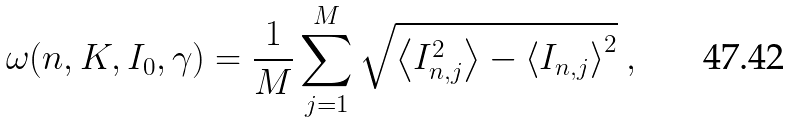<formula> <loc_0><loc_0><loc_500><loc_500>\omega ( n , K , I _ { 0 } , \gamma ) = \frac { 1 } { M } \sum ^ { M } _ { j = 1 } \sqrt { \left < I _ { n , j } ^ { 2 } \right > - \left < I _ { n , j } \right > ^ { 2 } } \ ,</formula> 